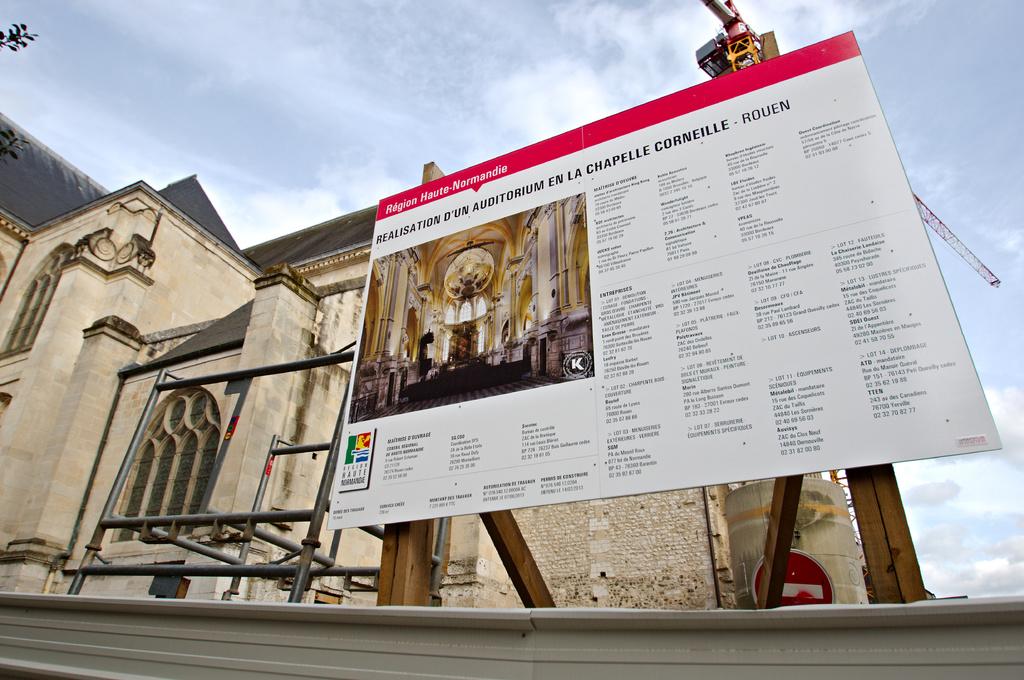What is written at the top in the red bar?
Give a very brief answer. Region haute-normandie. 